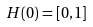<formula> <loc_0><loc_0><loc_500><loc_500>H ( 0 ) = [ 0 , 1 ]</formula> 